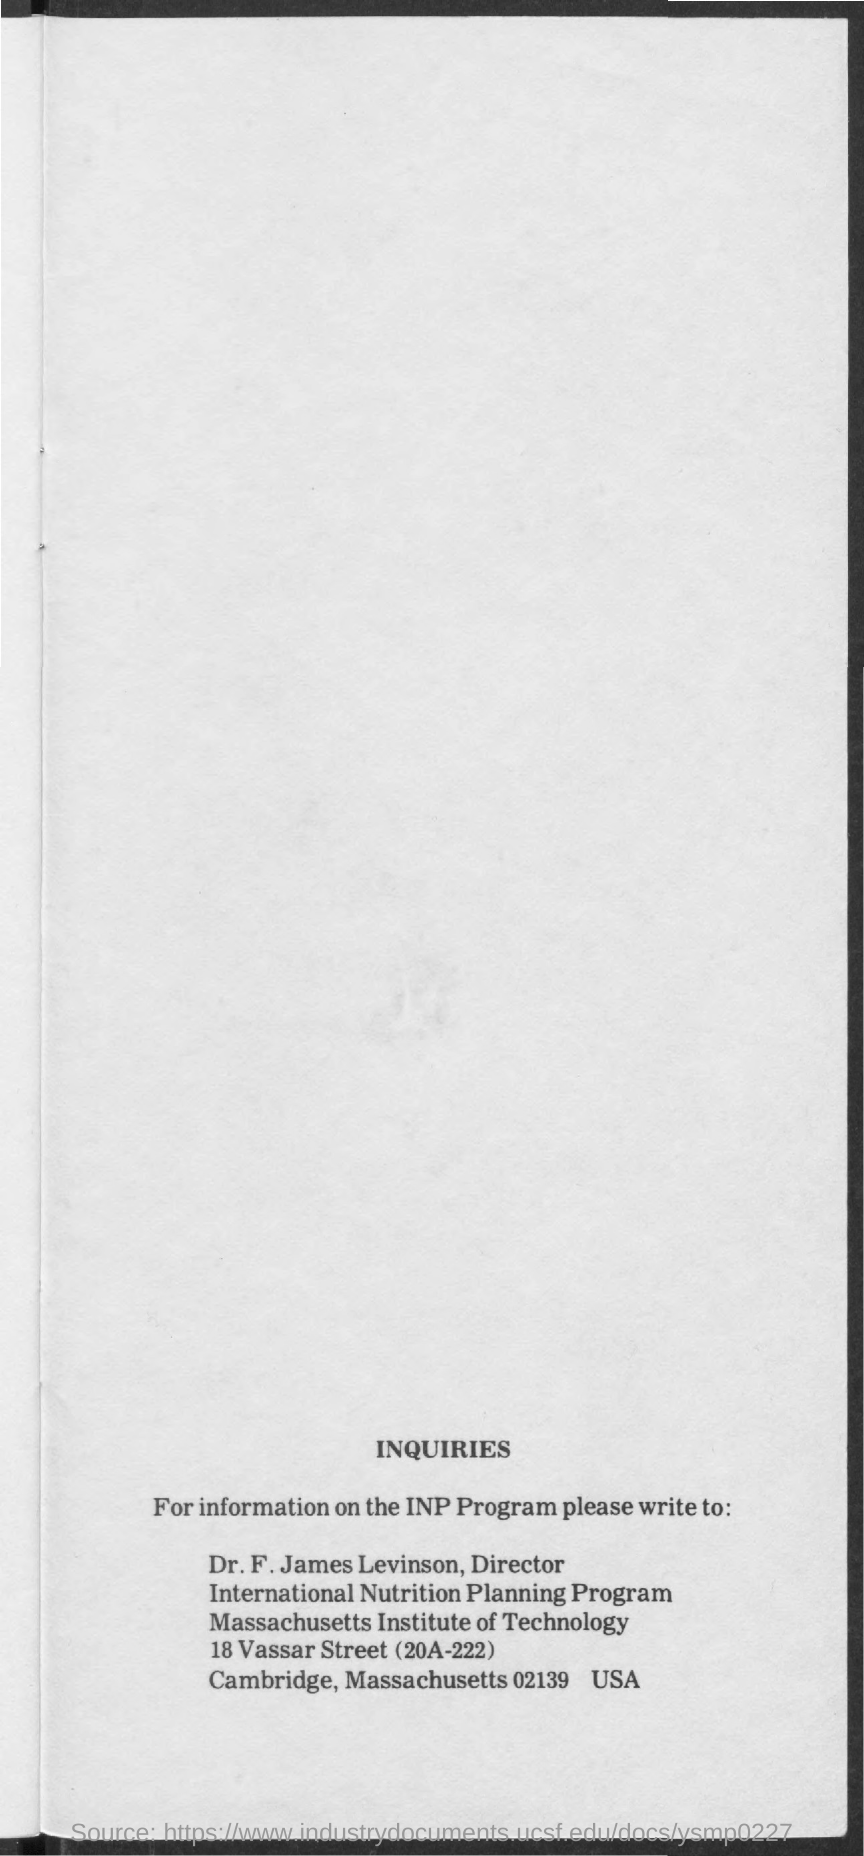What is the program mentioned ?
Your response must be concise. INTERNATIONAL NUTRITION PLANNING PROGRAM. What is the name of institute mentioned ?
Your answer should be very brief. Massachusetts institute of technology. What is the designation of dr. f. james levinson ?
Offer a very short reply. Director. 